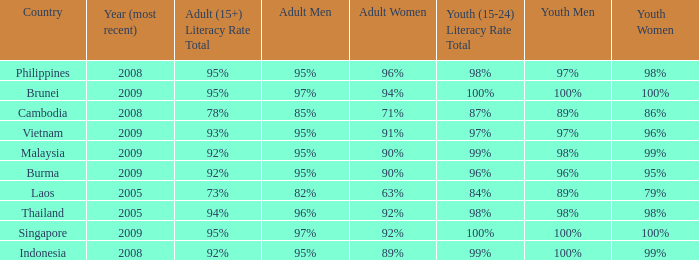Which country has its most recent year as being 2005 and has an Adult Men literacy rate of 96%? Thailand. 